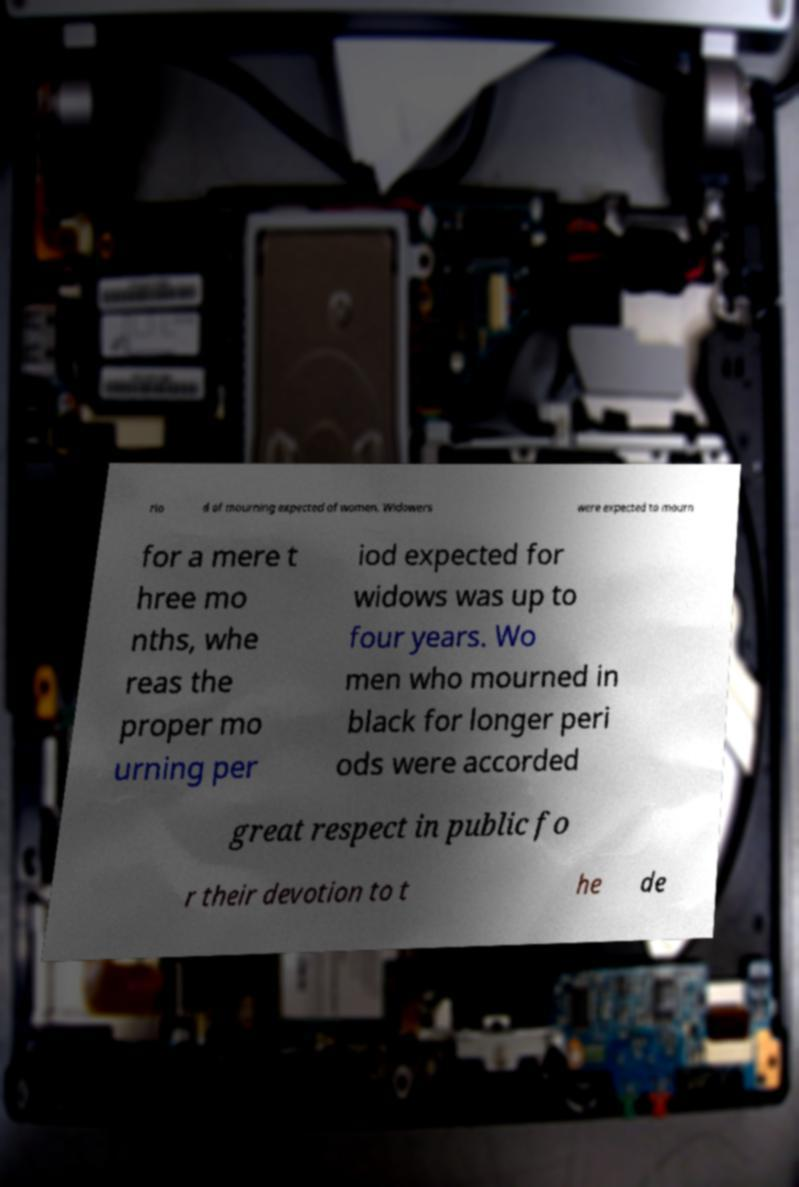I need the written content from this picture converted into text. Can you do that? rio d of mourning expected of women. Widowers were expected to mourn for a mere t hree mo nths, whe reas the proper mo urning per iod expected for widows was up to four years. Wo men who mourned in black for longer peri ods were accorded great respect in public fo r their devotion to t he de 